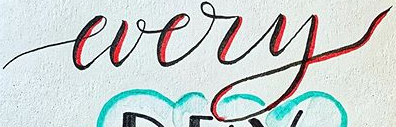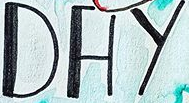Identify the words shown in these images in order, separated by a semicolon. every; DAY 